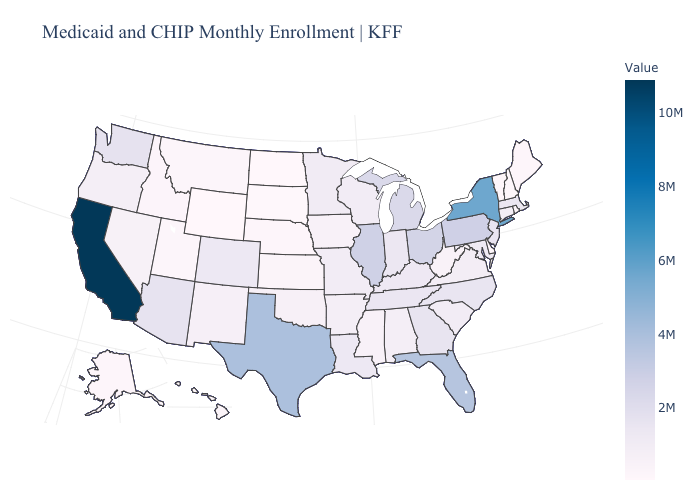Does Louisiana have a higher value than Pennsylvania?
Write a very short answer. No. Among the states that border Tennessee , does Missouri have the highest value?
Short answer required. No. Which states hav the highest value in the Northeast?
Write a very short answer. New York. Among the states that border New York , does Pennsylvania have the highest value?
Be succinct. Yes. Does New York have the lowest value in the USA?
Answer briefly. No. Does the map have missing data?
Keep it brief. No. 